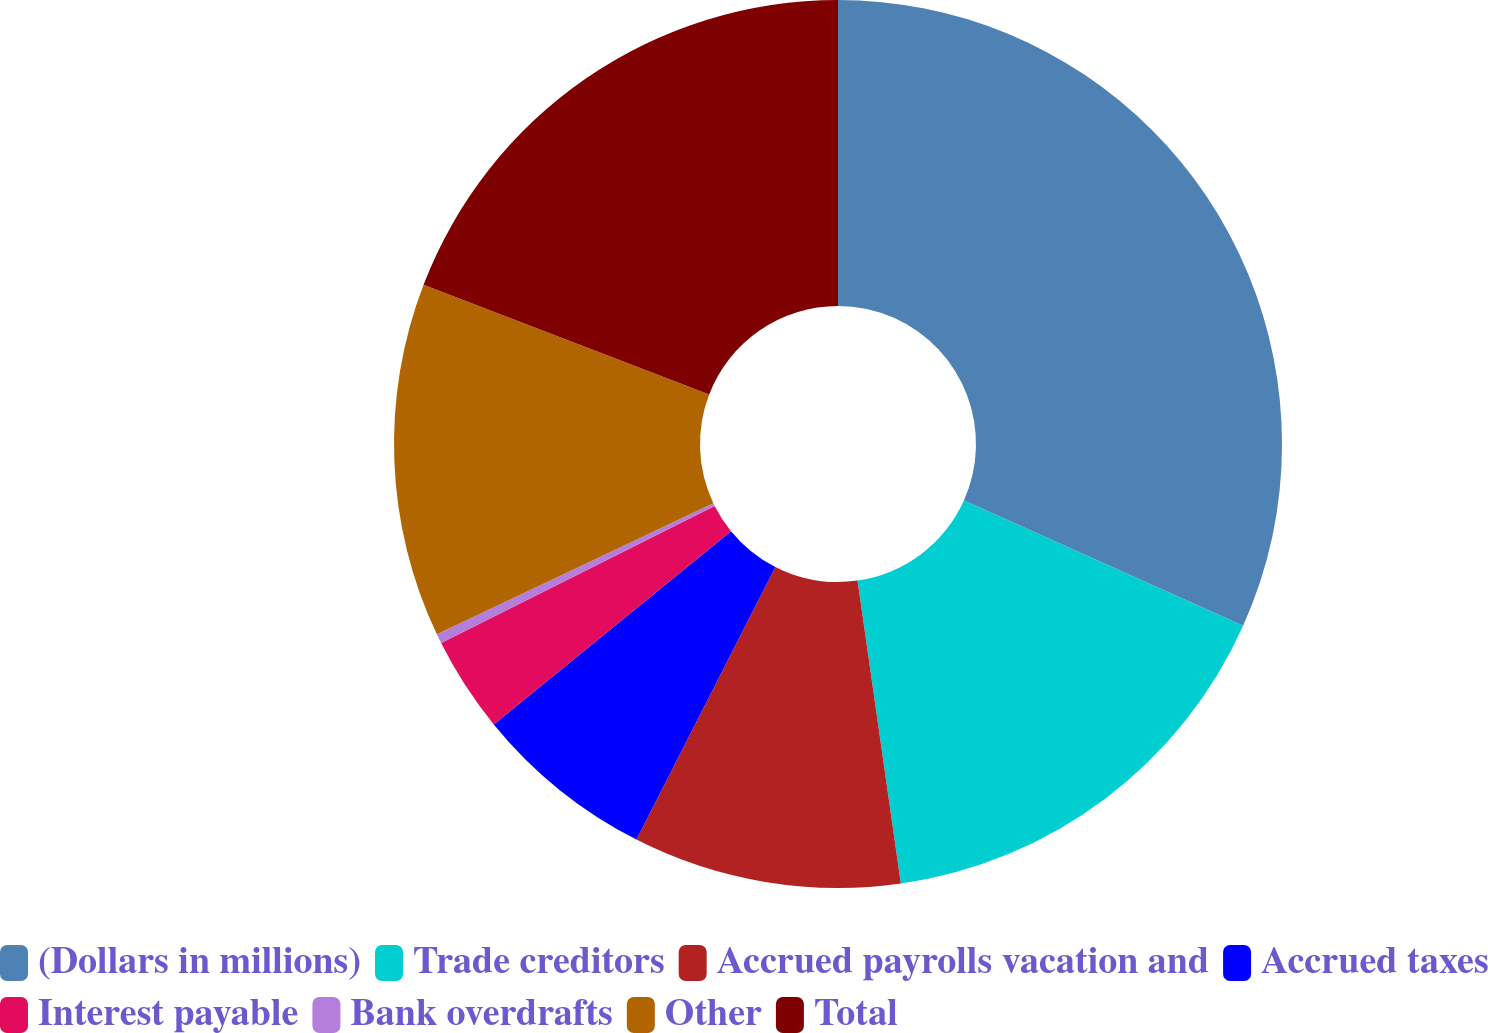<chart> <loc_0><loc_0><loc_500><loc_500><pie_chart><fcel>(Dollars in millions)<fcel>Trade creditors<fcel>Accrued payrolls vacation and<fcel>Accrued taxes<fcel>Interest payable<fcel>Bank overdrafts<fcel>Other<fcel>Total<nl><fcel>31.71%<fcel>16.03%<fcel>9.76%<fcel>6.62%<fcel>3.48%<fcel>0.35%<fcel>12.89%<fcel>19.16%<nl></chart> 